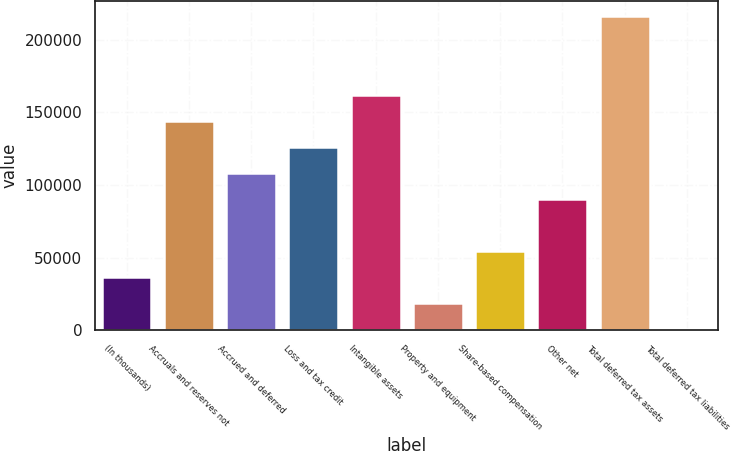<chart> <loc_0><loc_0><loc_500><loc_500><bar_chart><fcel>(In thousands)<fcel>Accruals and reserves not<fcel>Accrued and deferred<fcel>Loss and tax credit<fcel>Intangible assets<fcel>Property and equipment<fcel>Share-based compensation<fcel>Other net<fcel>Total deferred tax assets<fcel>Total deferred tax liabilities<nl><fcel>36686<fcel>144272<fcel>108410<fcel>126341<fcel>162203<fcel>18755<fcel>54617<fcel>90479<fcel>215996<fcel>824<nl></chart> 